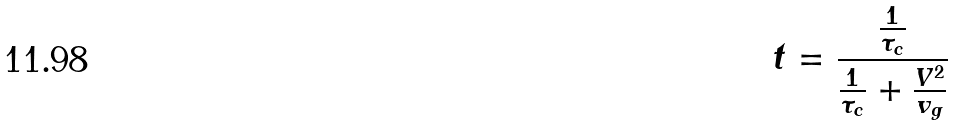<formula> <loc_0><loc_0><loc_500><loc_500>t = \frac { \frac { 1 } { \tau _ { c } } } { \frac { 1 } { \tau _ { c } } + \frac { V ^ { 2 } } { v _ { g } } }</formula> 